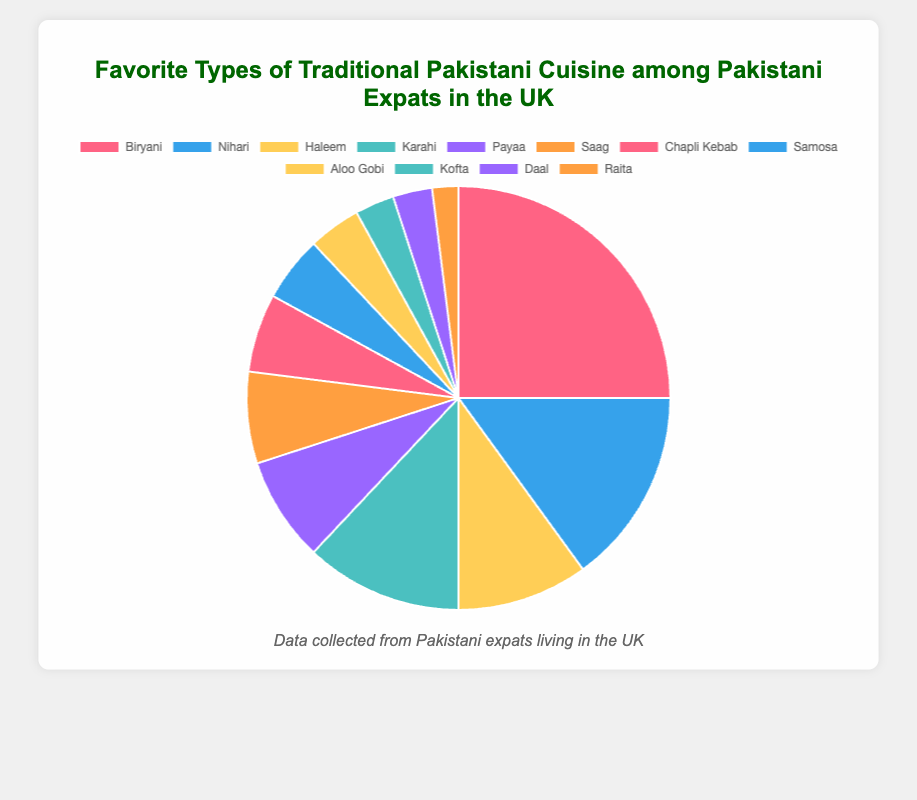What's the most popular type of traditional Pakistani cuisine among Pakistani expats in the UK? The largest slice of the pie chart corresponds to Biryani, labeled with a 25% share.
Answer: Biryani Which cuisine has a higher percentage, Nihari or Karahi? The pie chart shows that Nihari has a 15% share while Karahi has a 12% share. Therefore, Nihari has a higher percentage.
Answer: Nihari How much more popular is Biryani compared to Samosa? Biryani has a 25% share, and Samosa has a 5% share. The difference is obtained by subtracting 5% from 25%.
Answer: 20% What's the combined percentage of the least popular three cuisines? The least popular three cuisines are Raita (2%), Daal (3%), and Kofta (3%). Their combined percentage is 2% + 3% + 3% = 8%.
Answer: 8% Which cuisine has a lower percentage, Chapli Kebab or Aloo Gobi, and by how much? Chapli Kebab has a 6% share, and Aloo Gobi has a 4% share. Therefore, Aloo Gobi has a lower percentage by 6% - 4% = 2%.
Answer: Aloo Gobi by 2% What is the total percentage of expats who prefer cuisines other than Biryani? The total percentage distribution must sum up to 100%. Biryani has a 25% share. Therefore, the percentage who prefer other cuisines is 100% - 25% = 75%.
Answer: 75% Which cuisines have a percentage greater than 10%? The pie chart labels show that Biryani (25%), Nihari (15%), and Karahi (12%) all have shares greater than 10%.
Answer: Biryani, Nihari, Karahi How many cuisines have a share less than or equal to 5%? The pie chart labels indicate that Samosa (5%), Aloo Gobi (4%), Kofta (3%), Daal (3%), and Raita (2%) each have shares less than or equal to 5%. This sums up to 5 cuisines.
Answer: 5 